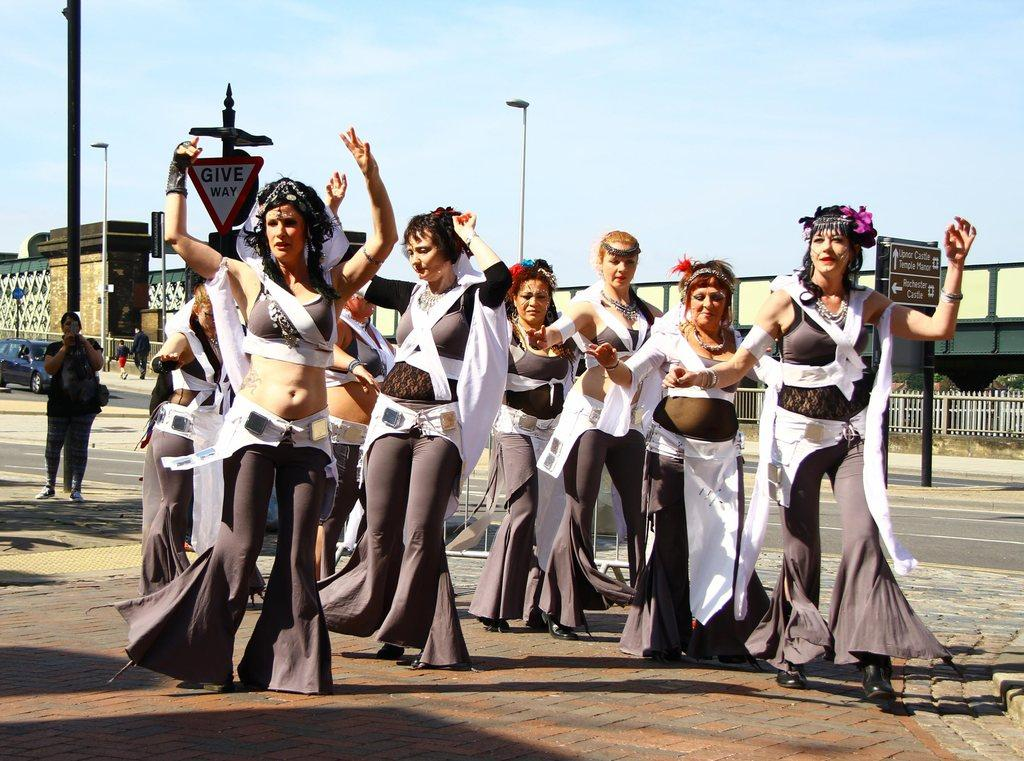Who is present in the image? There are women in the image. What are the women wearing? The women are wearing the same dress. What can be seen in the background of the image? There are buildings, trees, and poles in the image. What other objects are present in the image? There are boards in the image. What type of experience can be seen on the actor's face in the image? There is no actor present in the image, and therefore no facial expressions to analyze. 